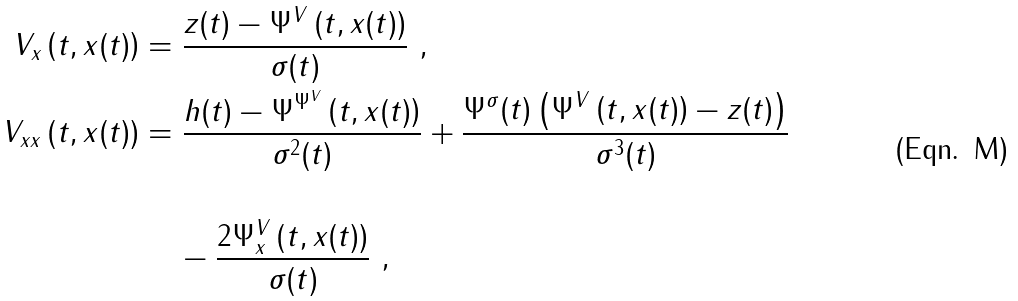<formula> <loc_0><loc_0><loc_500><loc_500>V _ { x } \left ( t , x ( t ) \right ) & = \frac { z ( t ) - \Psi ^ { V } \left ( t , x ( t ) \right ) } { \sigma ( t ) } \ , \\ V _ { x x } \left ( t , x ( t ) \right ) & = \frac { h ( t ) - \Psi ^ { \Psi ^ { V } } \left ( t , x ( t ) \right ) } { \sigma ^ { 2 } ( t ) } + \frac { \Psi ^ { \sigma } ( t ) \left ( \Psi ^ { V } \left ( t , x ( t ) \right ) - z ( t ) \right ) } { \sigma ^ { 3 } ( t ) } \\ \\ & \quad \, - \frac { 2 \Psi _ { x } ^ { V } \left ( t , x ( t ) \right ) } { \sigma ( t ) } \ ,</formula> 